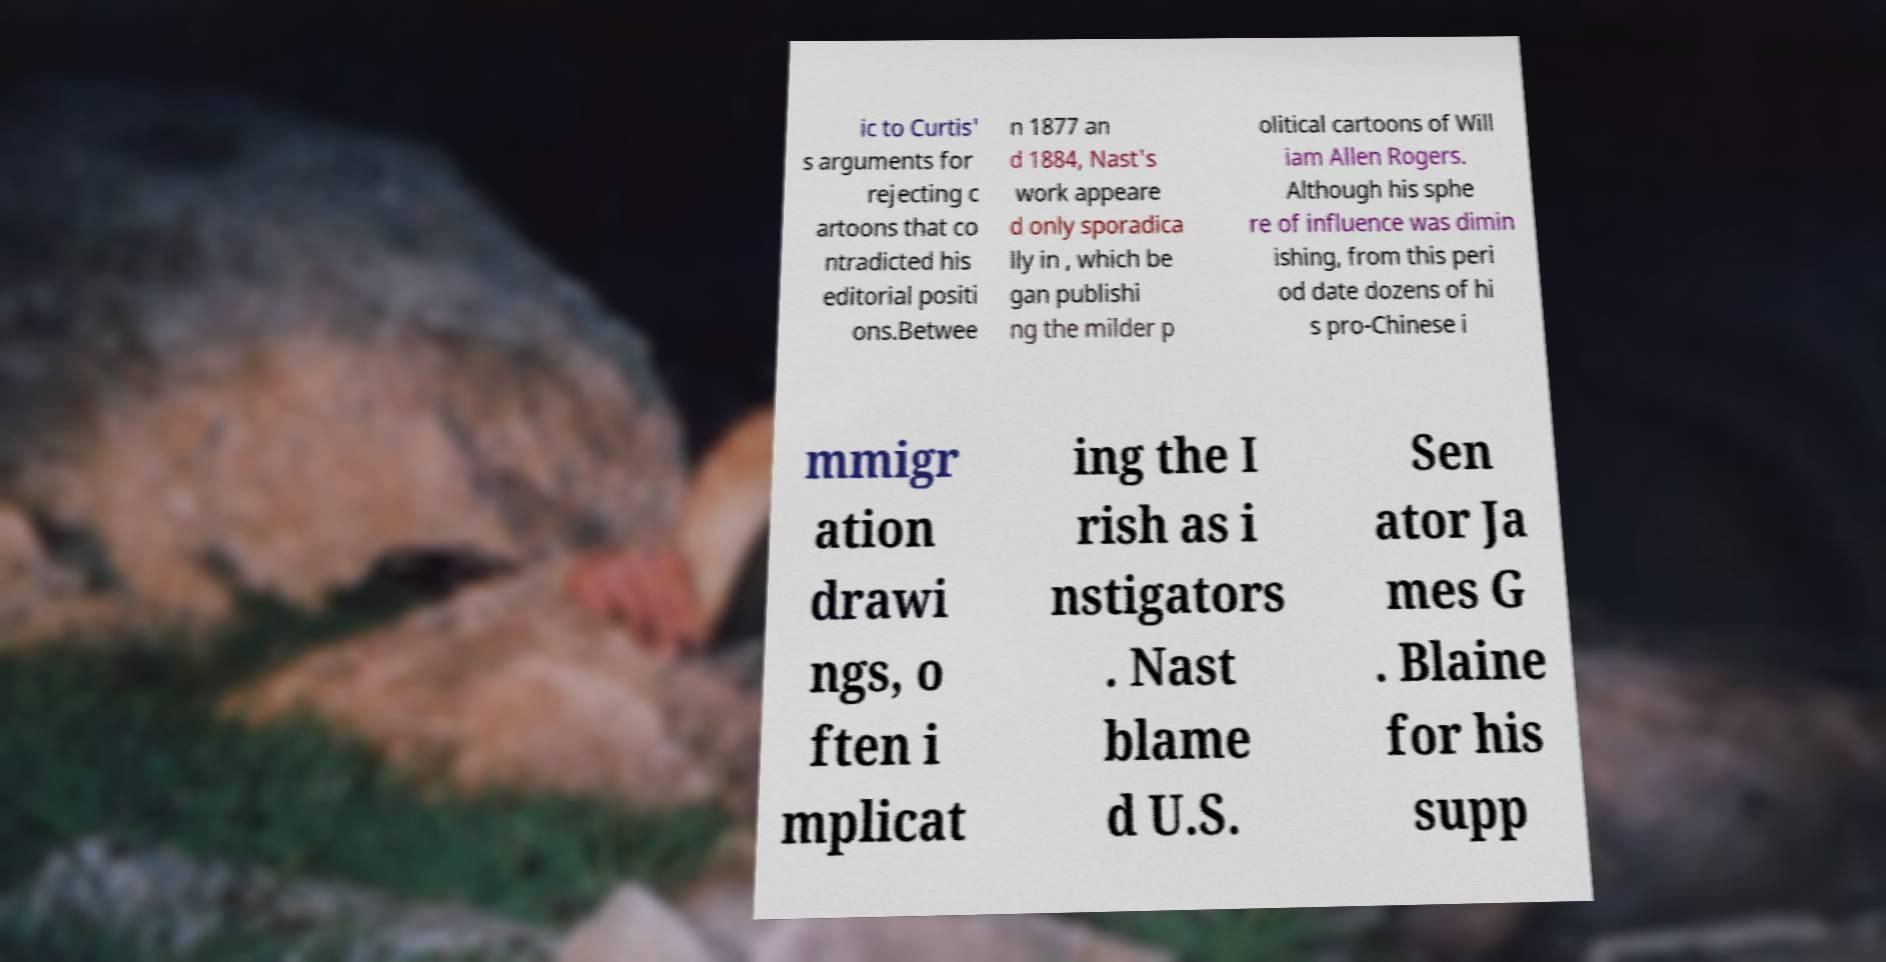There's text embedded in this image that I need extracted. Can you transcribe it verbatim? ic to Curtis' s arguments for rejecting c artoons that co ntradicted his editorial positi ons.Betwee n 1877 an d 1884, Nast's work appeare d only sporadica lly in , which be gan publishi ng the milder p olitical cartoons of Will iam Allen Rogers. Although his sphe re of influence was dimin ishing, from this peri od date dozens of hi s pro-Chinese i mmigr ation drawi ngs, o ften i mplicat ing the I rish as i nstigators . Nast blame d U.S. Sen ator Ja mes G . Blaine for his supp 